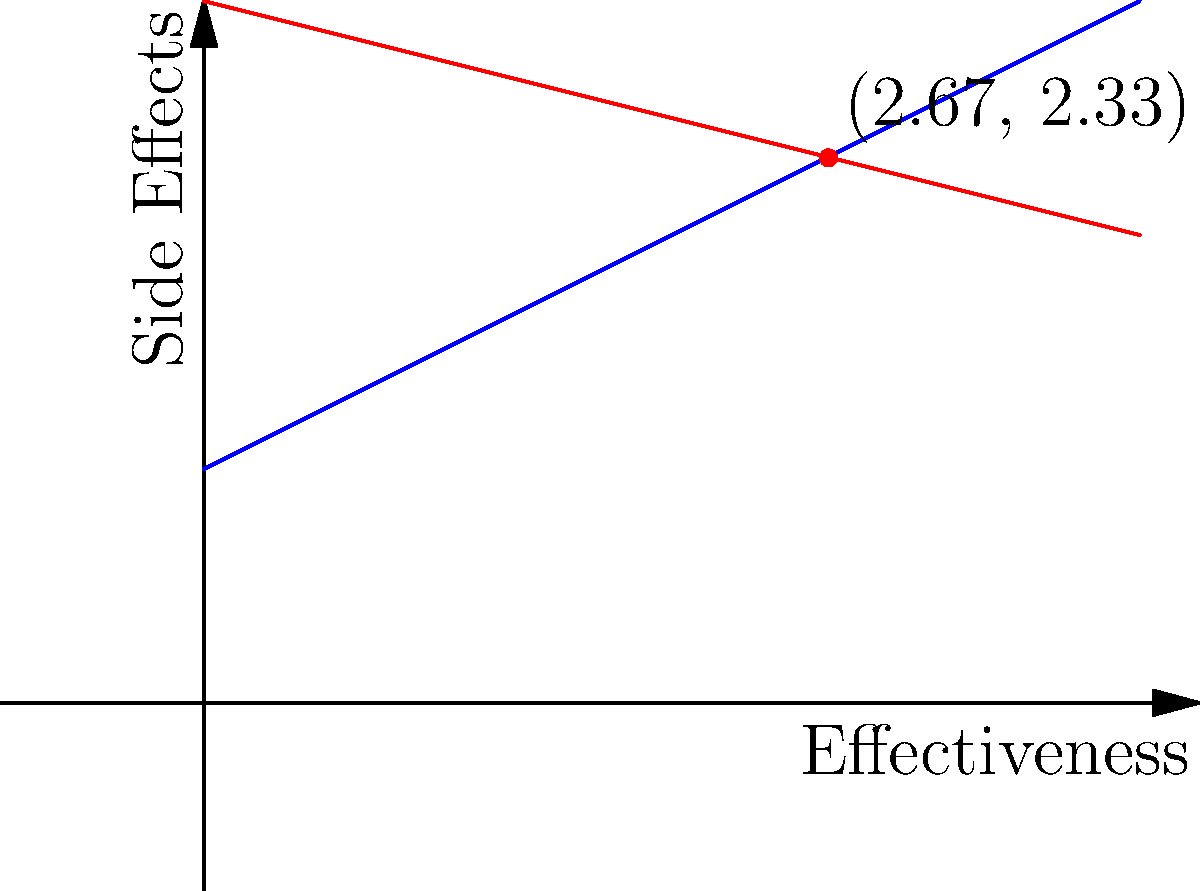In a clinical decision-making scenario, two cancer treatment options are represented by lines on a coordinate plane. Treatment A is represented by the equation $y = 0.5x + 1$, and Treatment B is represented by the equation $y = -0.25x + 3$, where $x$ represents the effectiveness of the treatment and $y$ represents the severity of side effects. At what point do these two treatment options intersect, and what does this intersection point signify in terms of treatment decision-making? To find the intersection point of the two lines, we need to solve the system of equations:

1) $y = 0.5x + 1$ (Treatment A)
2) $y = -0.25x + 3$ (Treatment B)

At the intersection point, both equations are true, so we can set them equal to each other:

3) $0.5x + 1 = -0.25x + 3$

Now, let's solve for x:

4) $0.5x + 0.25x = 3 - 1$
5) $0.75x = 2$
6) $x = 2.67$ (rounded to two decimal places)

To find y, we can substitute this x-value into either of the original equations. Let's use Treatment A's equation:

7) $y = 0.5(2.67) + 1$
8) $y = 1.33 + 1 = 2.33$

Therefore, the intersection point is (2.67, 2.33).

This point signifies where the two treatment options are equivalent in terms of their effectiveness and side effects. At this point, Treatment A and Treatment B offer the same balance of effectiveness (2.67) and side effect severity (2.33). 

For x-values less than 2.67, Treatment B has lower side effects but also lower effectiveness. For x-values greater than 2.67, Treatment A has a better balance of higher effectiveness with manageable side effects.

This intersection point can help in clinical decision-making by providing a threshold for choosing between treatments based on individual patient factors and preferences.
Answer: (2.67, 2.33); represents the point where treatments have equal effectiveness-to-side-effect ratios. 